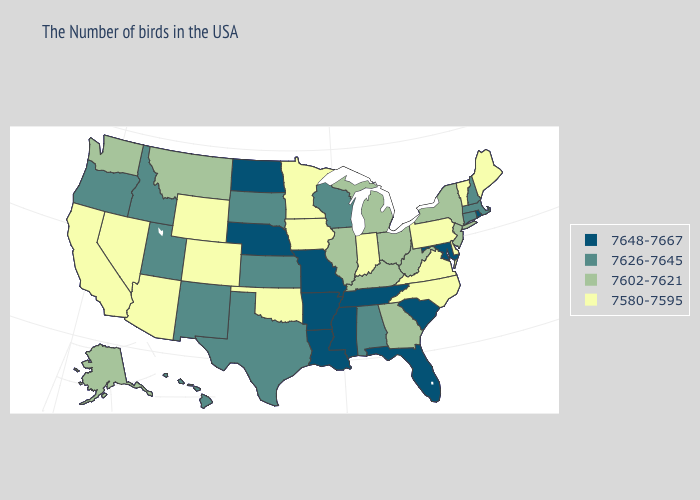Among the states that border Utah , does Nevada have the lowest value?
Quick response, please. Yes. Does the first symbol in the legend represent the smallest category?
Quick response, please. No. Does Louisiana have a higher value than Maryland?
Be succinct. No. What is the value of New Jersey?
Quick response, please. 7602-7621. Does the map have missing data?
Concise answer only. No. Name the states that have a value in the range 7580-7595?
Quick response, please. Maine, Vermont, Delaware, Pennsylvania, Virginia, North Carolina, Indiana, Minnesota, Iowa, Oklahoma, Wyoming, Colorado, Arizona, Nevada, California. What is the value of North Carolina?
Write a very short answer. 7580-7595. What is the highest value in the West ?
Answer briefly. 7626-7645. Does Nebraska have a higher value than Utah?
Concise answer only. Yes. What is the highest value in states that border Idaho?
Short answer required. 7626-7645. Does Oregon have a lower value than Nebraska?
Short answer required. Yes. Name the states that have a value in the range 7602-7621?
Answer briefly. New York, New Jersey, West Virginia, Ohio, Georgia, Michigan, Kentucky, Illinois, Montana, Washington, Alaska. Which states have the lowest value in the USA?
Answer briefly. Maine, Vermont, Delaware, Pennsylvania, Virginia, North Carolina, Indiana, Minnesota, Iowa, Oklahoma, Wyoming, Colorado, Arizona, Nevada, California. What is the value of Maine?
Be succinct. 7580-7595. 